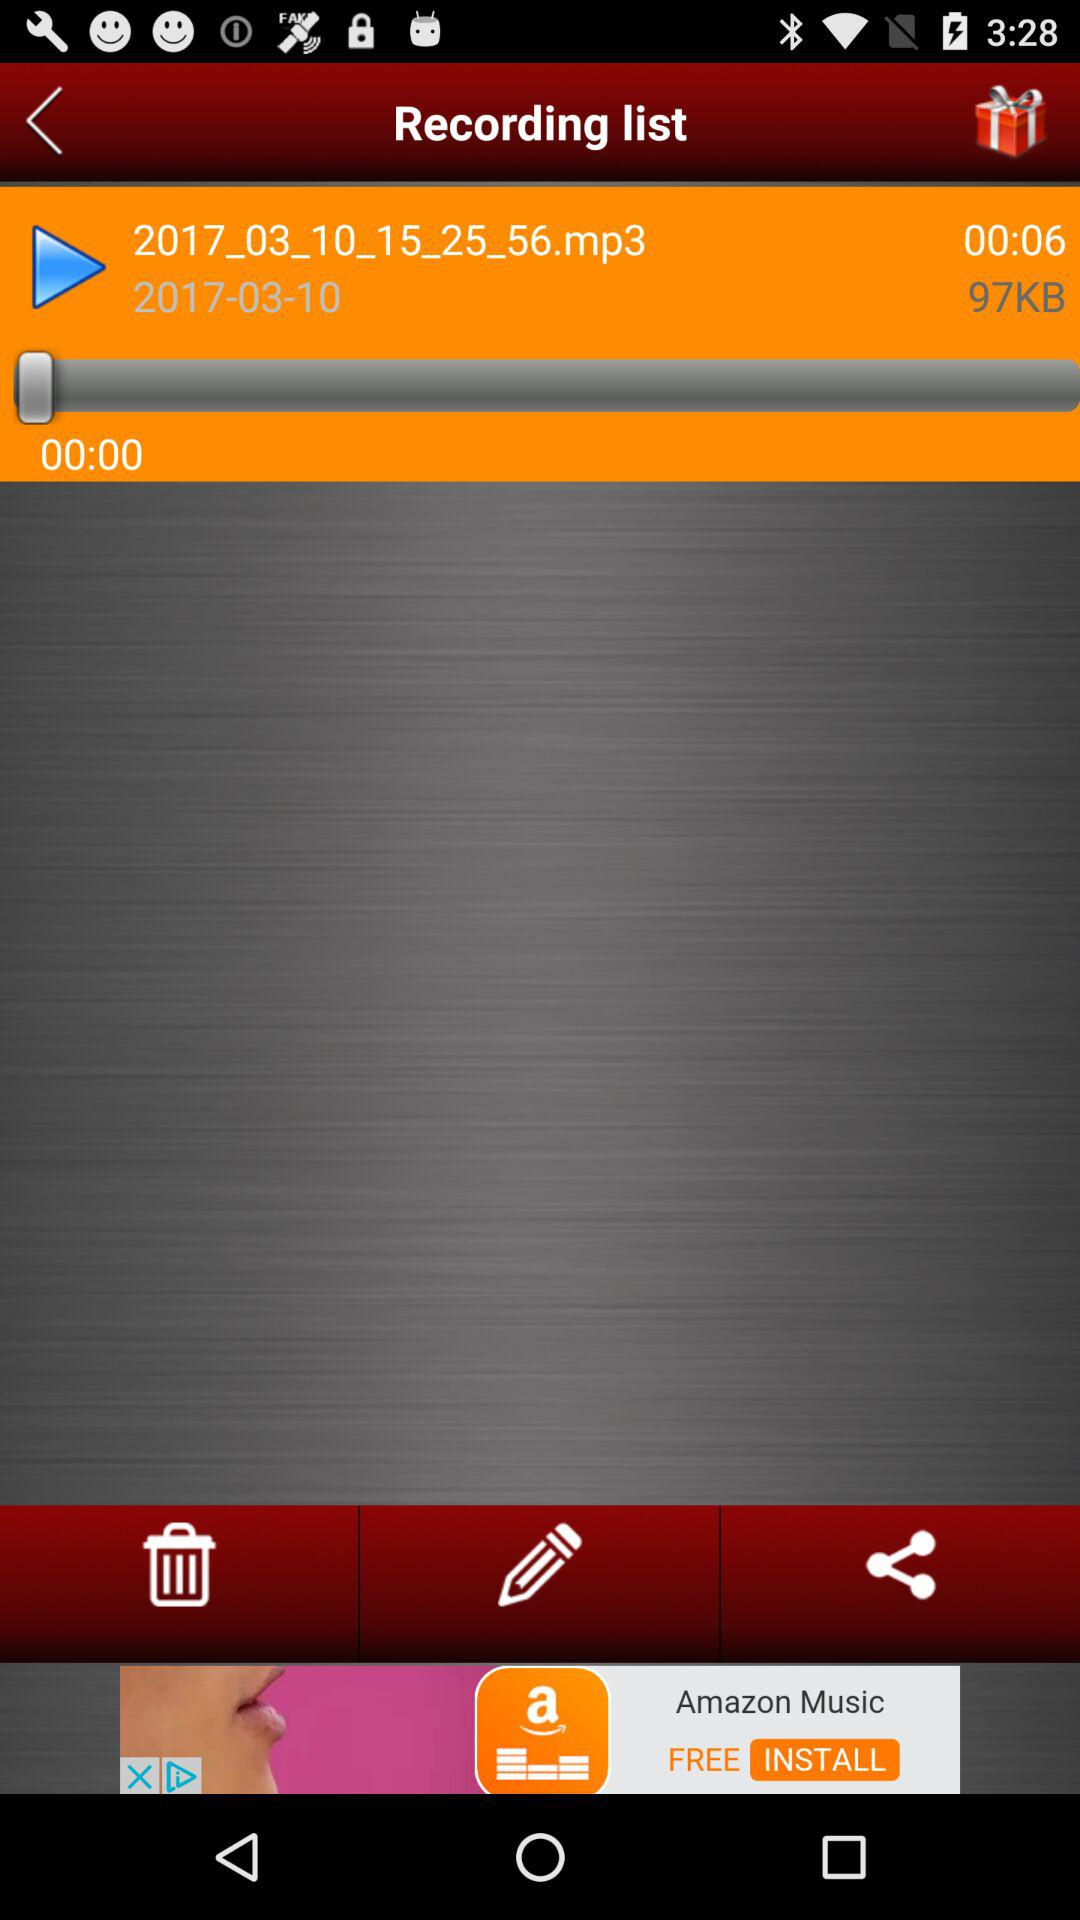On what date was the audio recorded? The audio was recorded on March 10, 2017. 